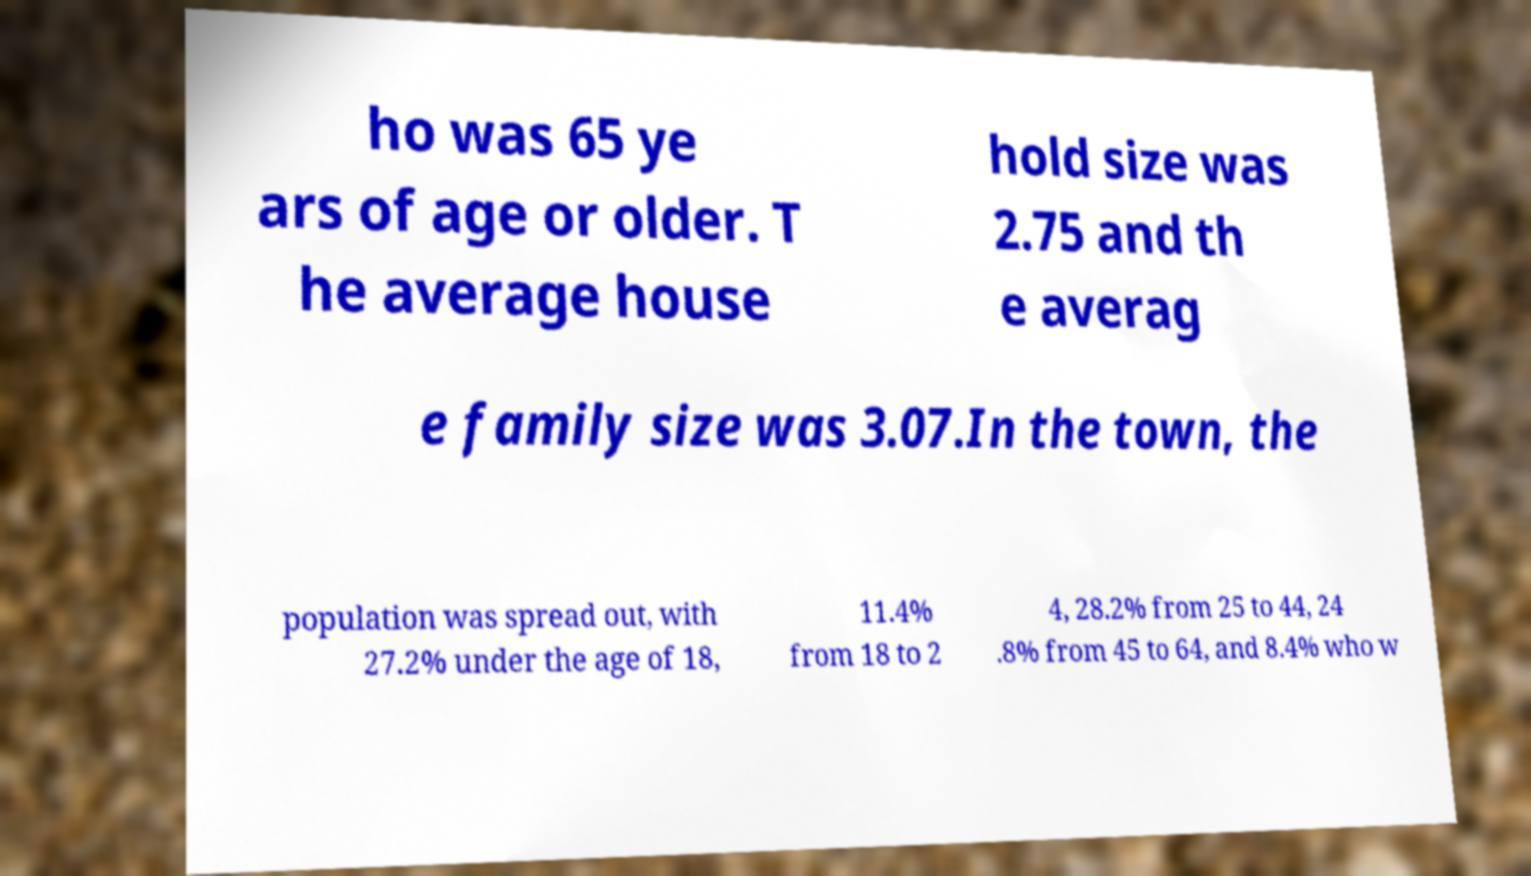Can you accurately transcribe the text from the provided image for me? ho was 65 ye ars of age or older. T he average house hold size was 2.75 and th e averag e family size was 3.07.In the town, the population was spread out, with 27.2% under the age of 18, 11.4% from 18 to 2 4, 28.2% from 25 to 44, 24 .8% from 45 to 64, and 8.4% who w 